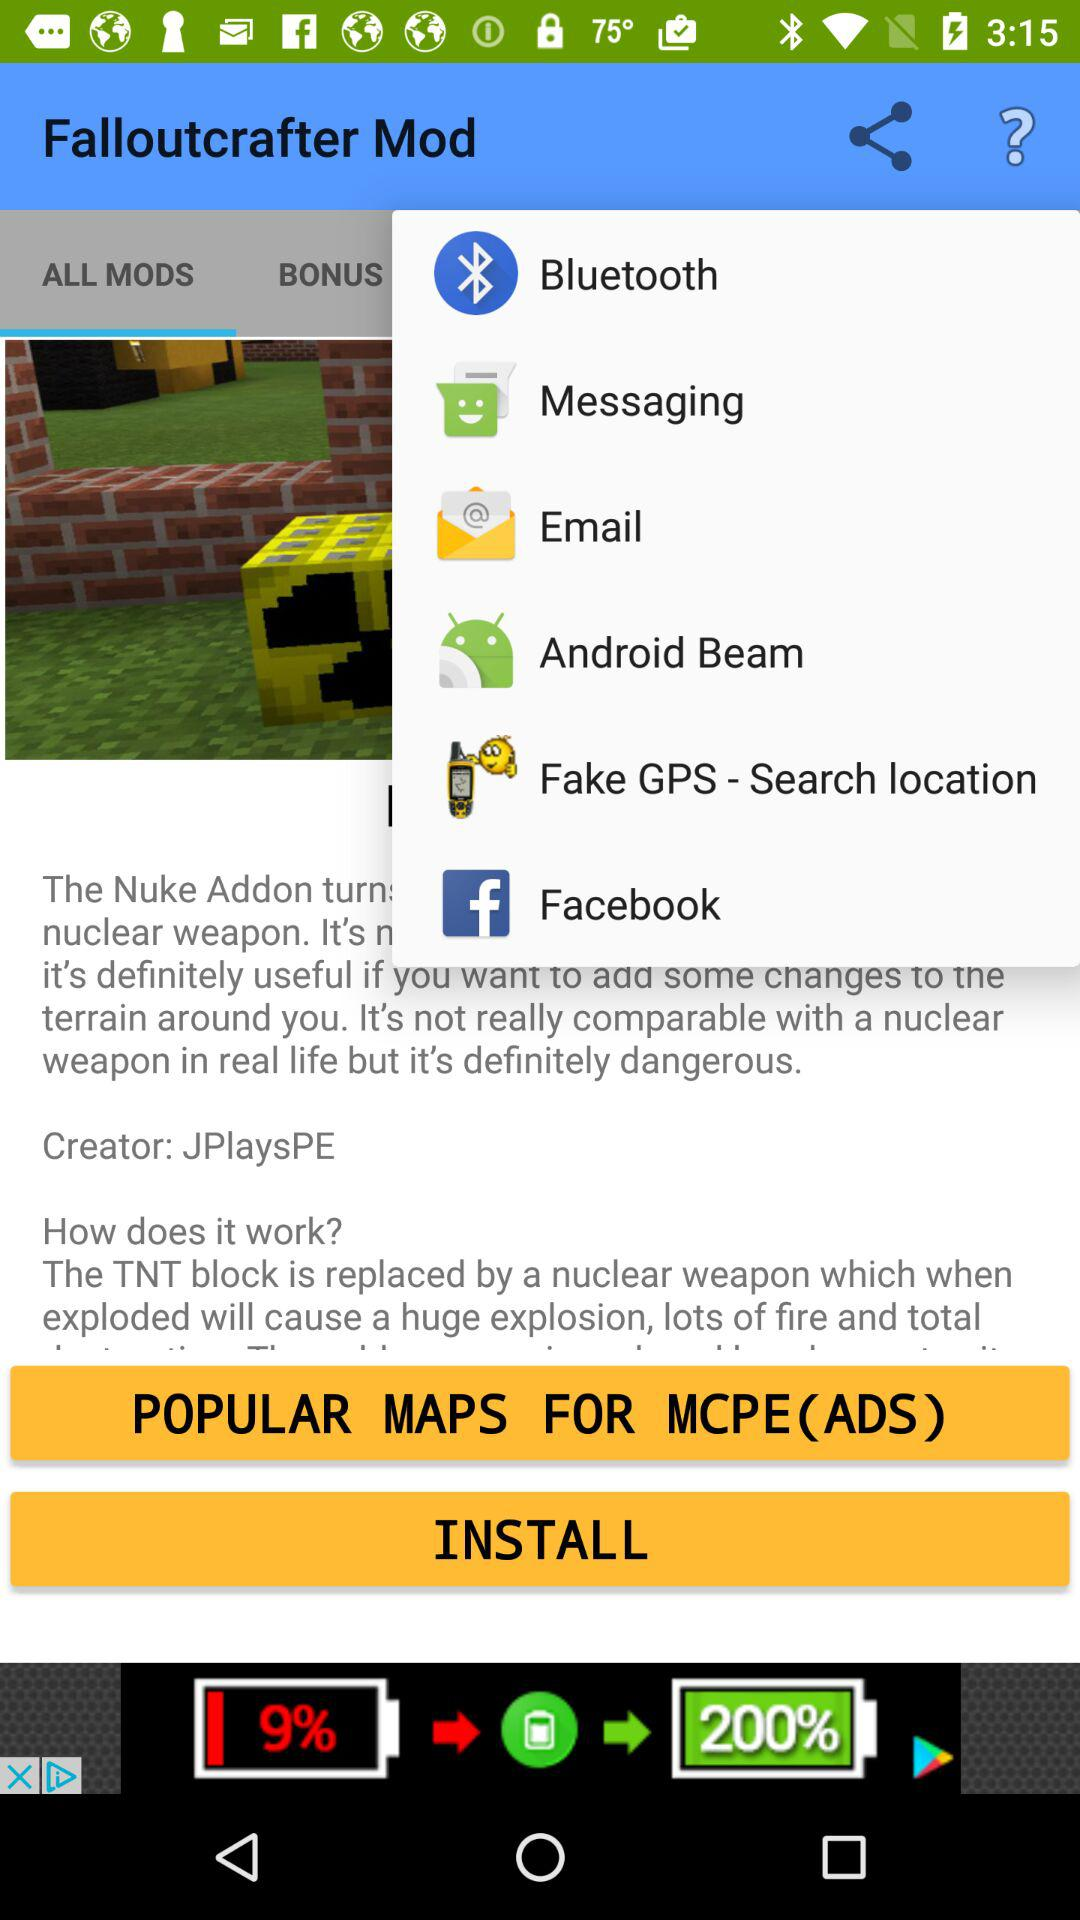Which tab has been selected? The selected tab is "ALL MODS". 